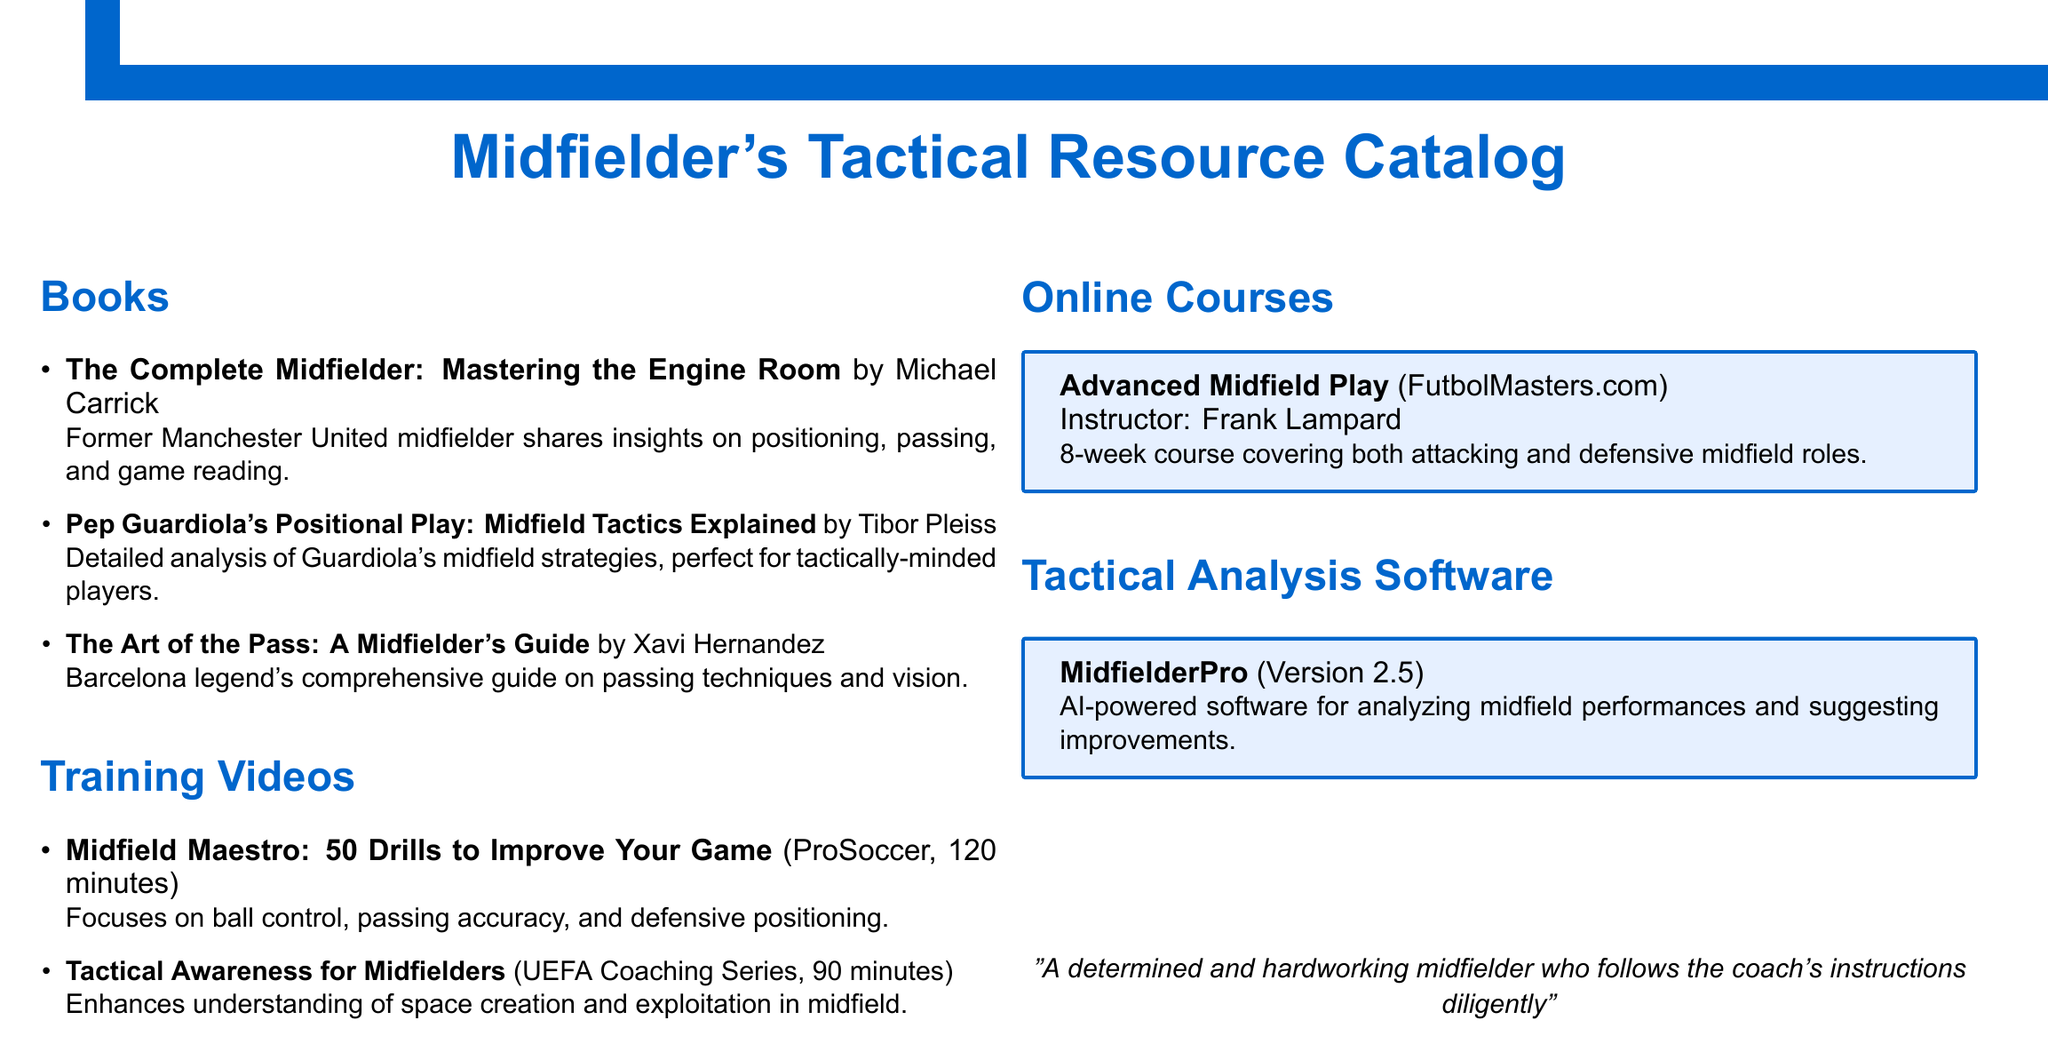What is the title of the first book listed? The first book title can be found in the list under the "Books" section.
Answer: The Complete Midfielder: Mastering the Engine Room Who is the author of "Pep Guardiola's Positional Play"? The author of this book is mentioned next to the title under the "Books" section.
Answer: Tibor Pleiss What is the duration of the video "Midfield Maestro: 50 Drills to Improve Your Game"? The duration is specified next to the video title in the "Training Videos" section.
Answer: 120 minutes How long is the online course "Advanced Midfield Play"? The duration of the course is described in the instructor details in the "Online Courses" section.
Answer: 8-week What type of software is "MidfielderPro"? The type of software is indicated in the description under the "Tactical Analysis Software" section.
Answer: AI-powered What does the book "The Art of the Pass" focus on? The focus of the book is detailed in the description next to the title under the "Books" section.
Answer: Passing techniques and vision Who is the instructor for the course listed? The instructor's name is given clearly in the course details within the "Online Courses" section.
Answer: Frank Lampard Which training video enhances understanding of space creation? The specific training video is mentioned in the "Training Videos" section.
Answer: Tactical Awareness for Midfielders 